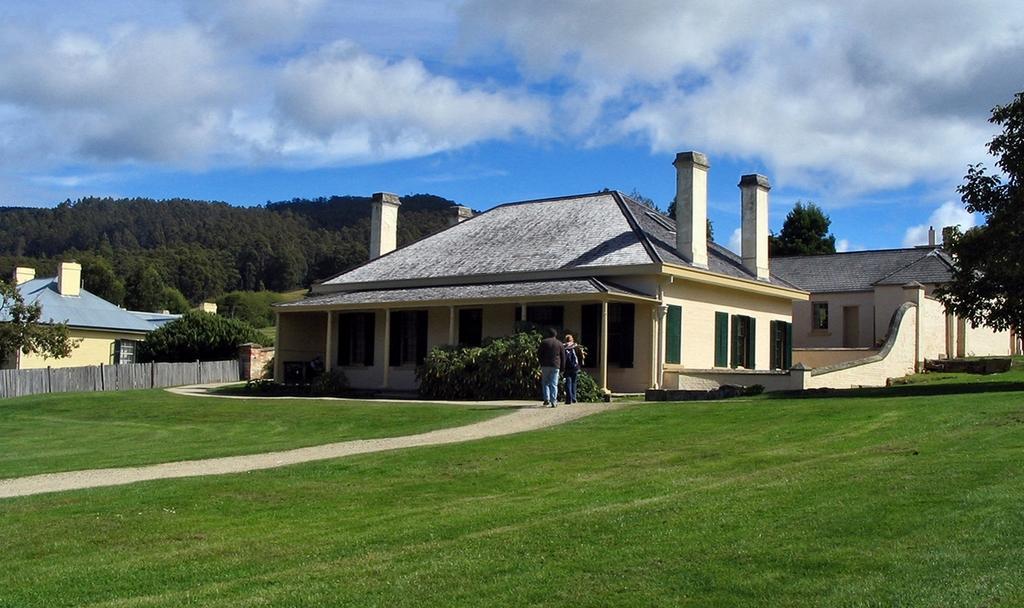How would you summarize this image in a sentence or two? In this image we can see two people walking on the pathway. We can also see some houses with roof and windows, a wooden fence, grass, plants, a group of trees and the sky which looks cloudy. 